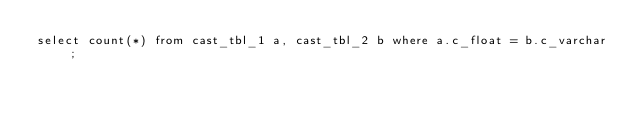Convert code to text. <code><loc_0><loc_0><loc_500><loc_500><_SQL_>select count(*) from cast_tbl_1 a, cast_tbl_2 b where a.c_float = b.c_varchar;
</code> 